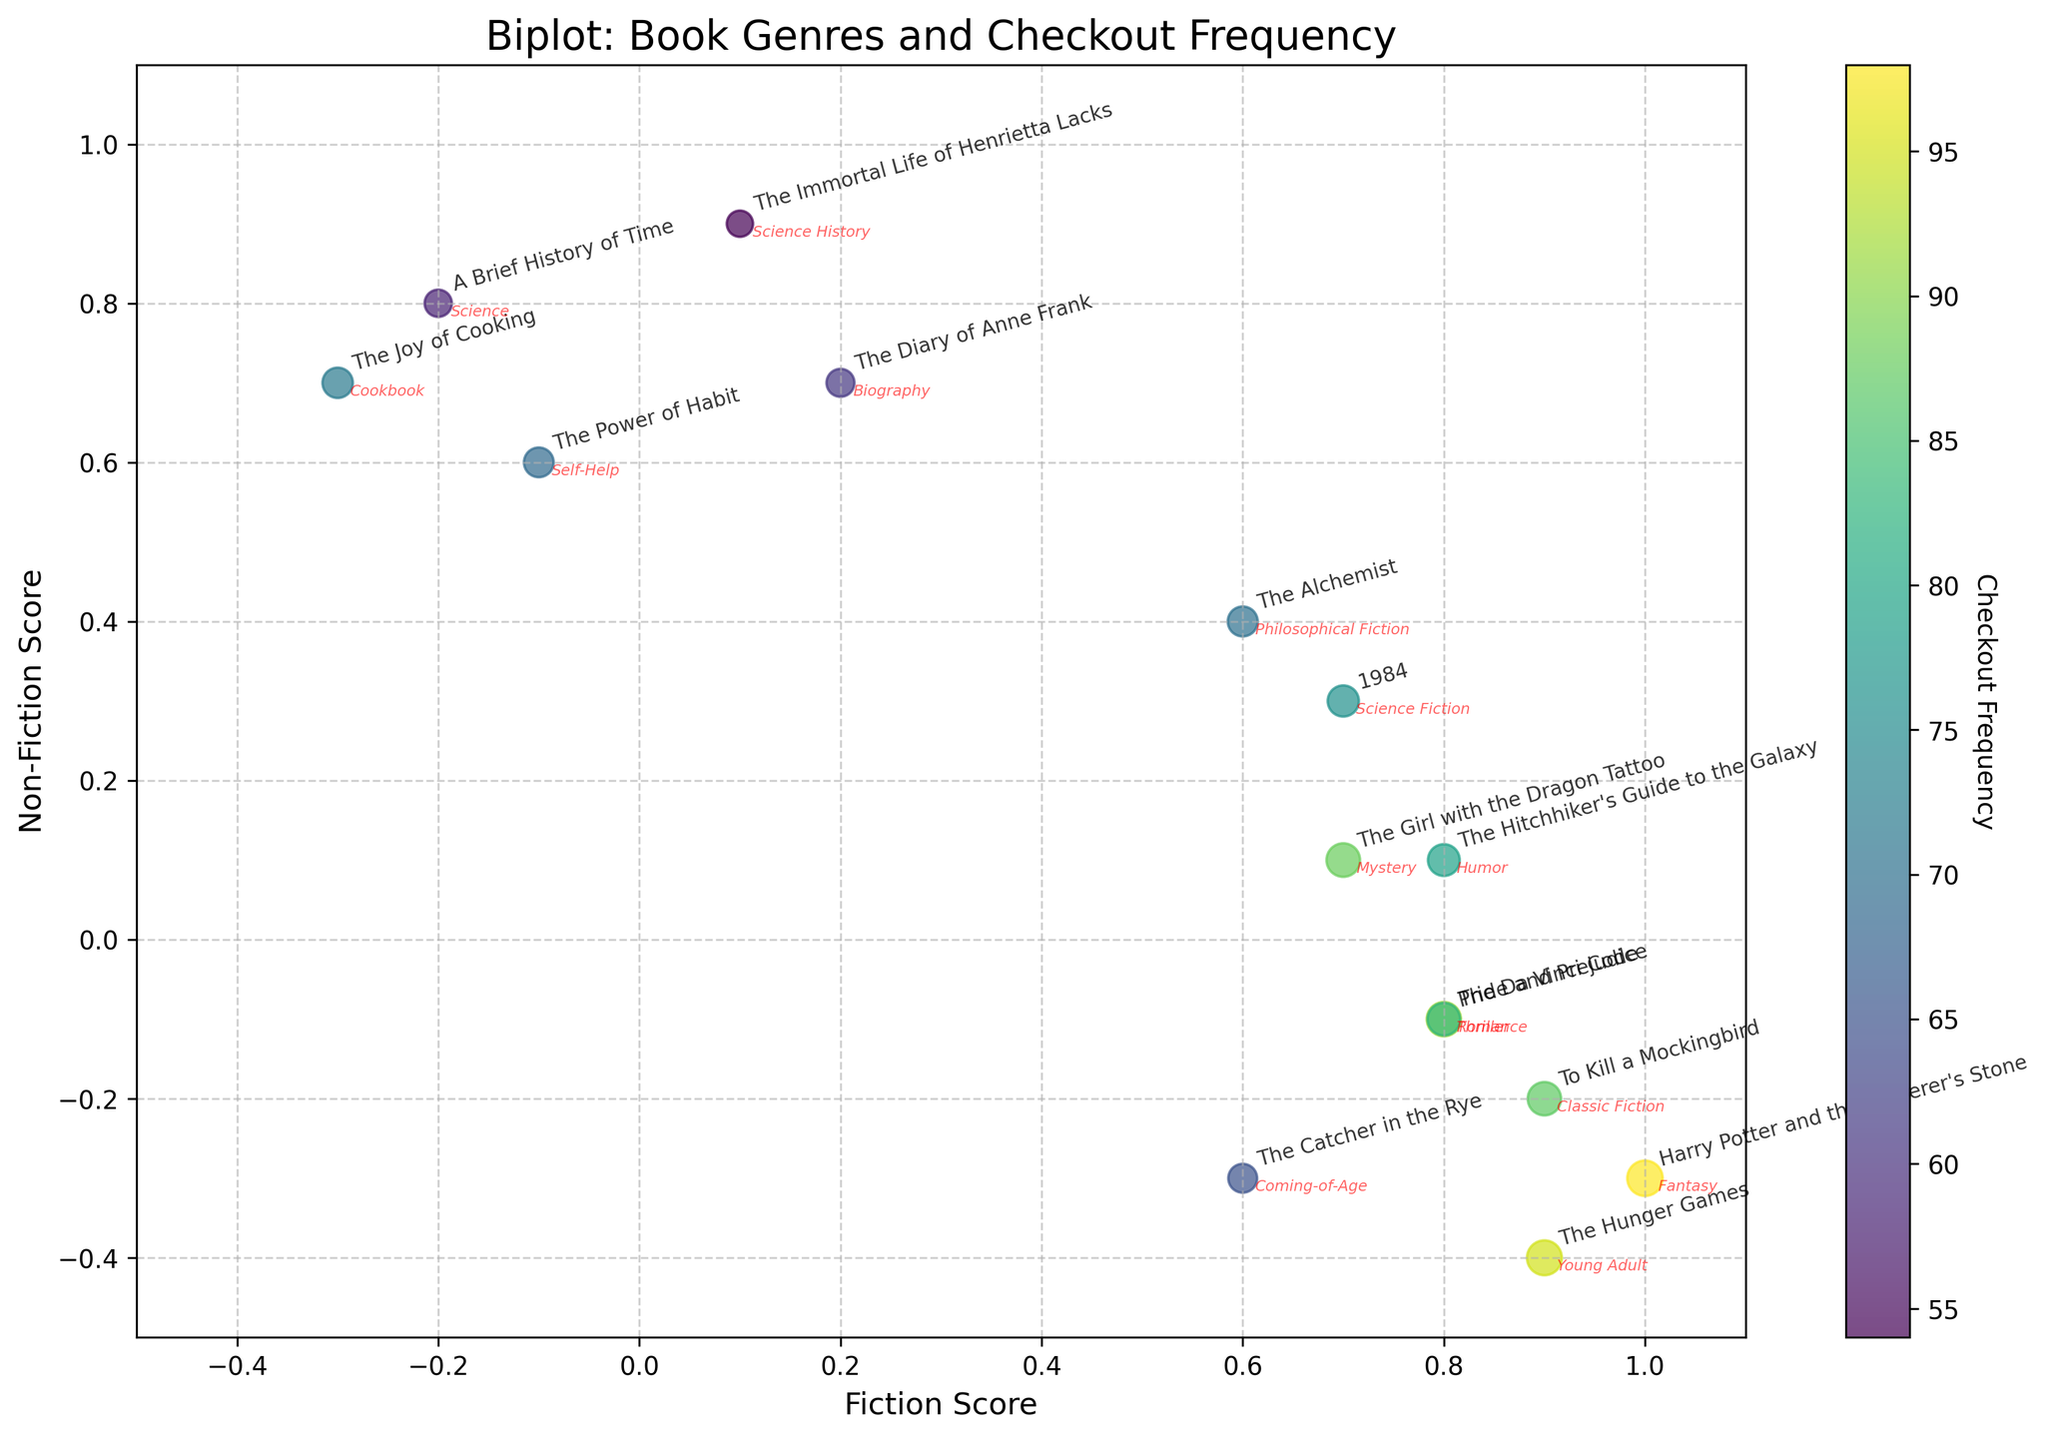what is the title of the figure? The title is typically located at the top of the figure in a prominent position. In this case, it reads, "Biplot: Book Genres and Checkout Frequency."
Answer: Biplot: Book Genres and Checkout Frequency what are the labels of the axes? The labels of axes can be found near the horizontal and vertical lines of the graph. The x-axis label is "Fiction Score," and the y-axis label is "Non-Fiction Score."
Answer: Fiction Score (x-axis) and Non-Fiction Score (y-axis) how many genres have a fiction score of 0.8? Genres with a fiction score of 0.8 match points along the 0.8 mark on the x-axis: "The Da Vinci Code," "Pride and Prejudice," and "The Hitchhiker's Guide to the Galaxy."
Answer: Three genres which book has the highest checkout frequency? The book with the largest point and the most intense color on the colorbar represents the highest checkout frequency. This is "Harry Potter and the Sorcerer's Stone."
Answer: Harry Potter and the Sorcerer's Stone which genres fall outside the range of (0.5, 0.5) to (1, 1) for their combined scores? First, identify the genres whose points fall outside the provided range by examining their x and y positions. These genres include books like "A Brief History of Time," "The Joy of Cooking," and others clearly outside this score range.
Answer: Numerous genres, e.g., "A Brief History of Time," "The Joy of Cooking" is there a pattern between fiction and non-fiction scores and book genres? By observing the scatter plot, we notice that fiction-heavy books (higher on the fiction score) tend to have lower non-fiction scores and vice versa. For example, "Harry Potter and the Sorcerer's Stone" has a high fiction score but low non-fiction score.
Answer: Fiction and Non-Fiction scores are inversely related for many genres which book titles fall into the upper right quadrant of the figure? Points in the upper-right quadrant have high values for both fiction and non-fiction scores (positive values on both axes). Examples include "1984" and "The Immortal Life of Henrietta Lacks."
Answer: "1984," "The Immortal Life of Henrietta Lacks" which books have a non-fiction score below 0? Points below the horizontal zero line of the y-axis have negative non-fiction scores. These books include titles like "To Kill a Mockingbird," "The Da Vinci Code," and "The Hunger Games."
Answer: "To Kill a Mockingbird," "The Da Vinci Code," "The Hunger Games" what correlation can be observed between the size of points and checkout frequency? Larger points are proportional to higher checkout frequencies. Thus, "Harry Potter and the Sorcerer's Stone" has the largest point, indicating a high checkout frequency.
Answer: Larger points indicate higher checkout frequency 